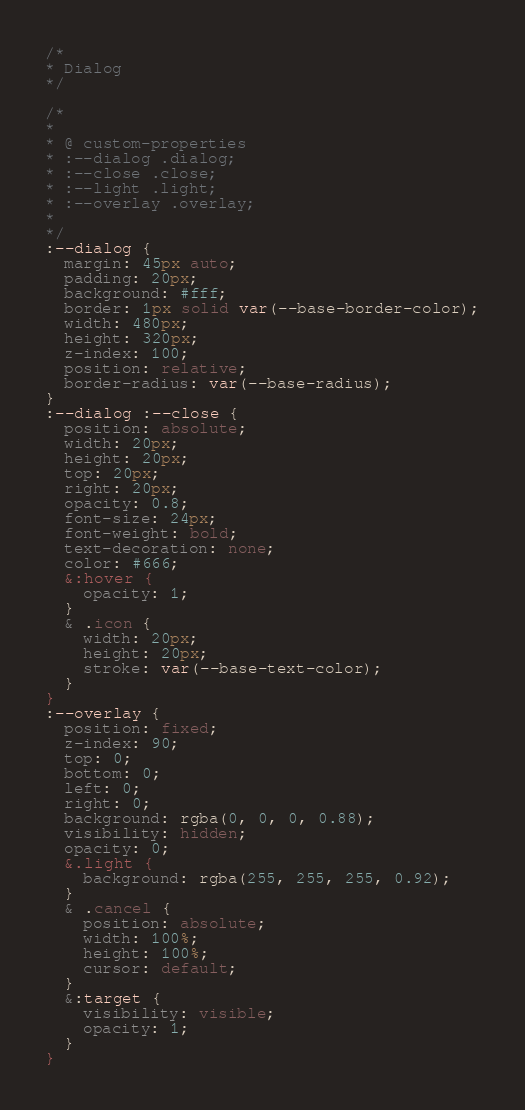Convert code to text. <code><loc_0><loc_0><loc_500><loc_500><_CSS_>/*
* Dialog
*/

/*
*
* @ custom-properties
* :--dialog .dialog;
* :--close .close;
* :--light .light;
* :--overlay .overlay;
*
*/
:--dialog {
  margin: 45px auto;
  padding: 20px;
  background: #fff;
  border: 1px solid var(--base-border-color);
  width: 480px;
  height: 320px;
  z-index: 100;
  position: relative;
  border-radius: var(--base-radius);
}
:--dialog :--close {
  position: absolute;
  width: 20px;
  height: 20px;
  top: 20px;
  right: 20px;
  opacity: 0.8;
  font-size: 24px;
  font-weight: bold;
  text-decoration: none;
  color: #666;
  &:hover {
    opacity: 1;
  }
  & .icon {
    width: 20px;
    height: 20px;
    stroke: var(--base-text-color);
  }
}
:--overlay {
  position: fixed;
  z-index: 90;
  top: 0;
  bottom: 0;
  left: 0;
  right: 0;
  background: rgba(0, 0, 0, 0.88);
  visibility: hidden;
  opacity: 0;
  &.light {
    background: rgba(255, 255, 255, 0.92);
  }
  & .cancel {
    position: absolute;
    width: 100%;
    height: 100%;
    cursor: default;
  }
  &:target {
    visibility: visible;
    opacity: 1;
  }
}</code> 